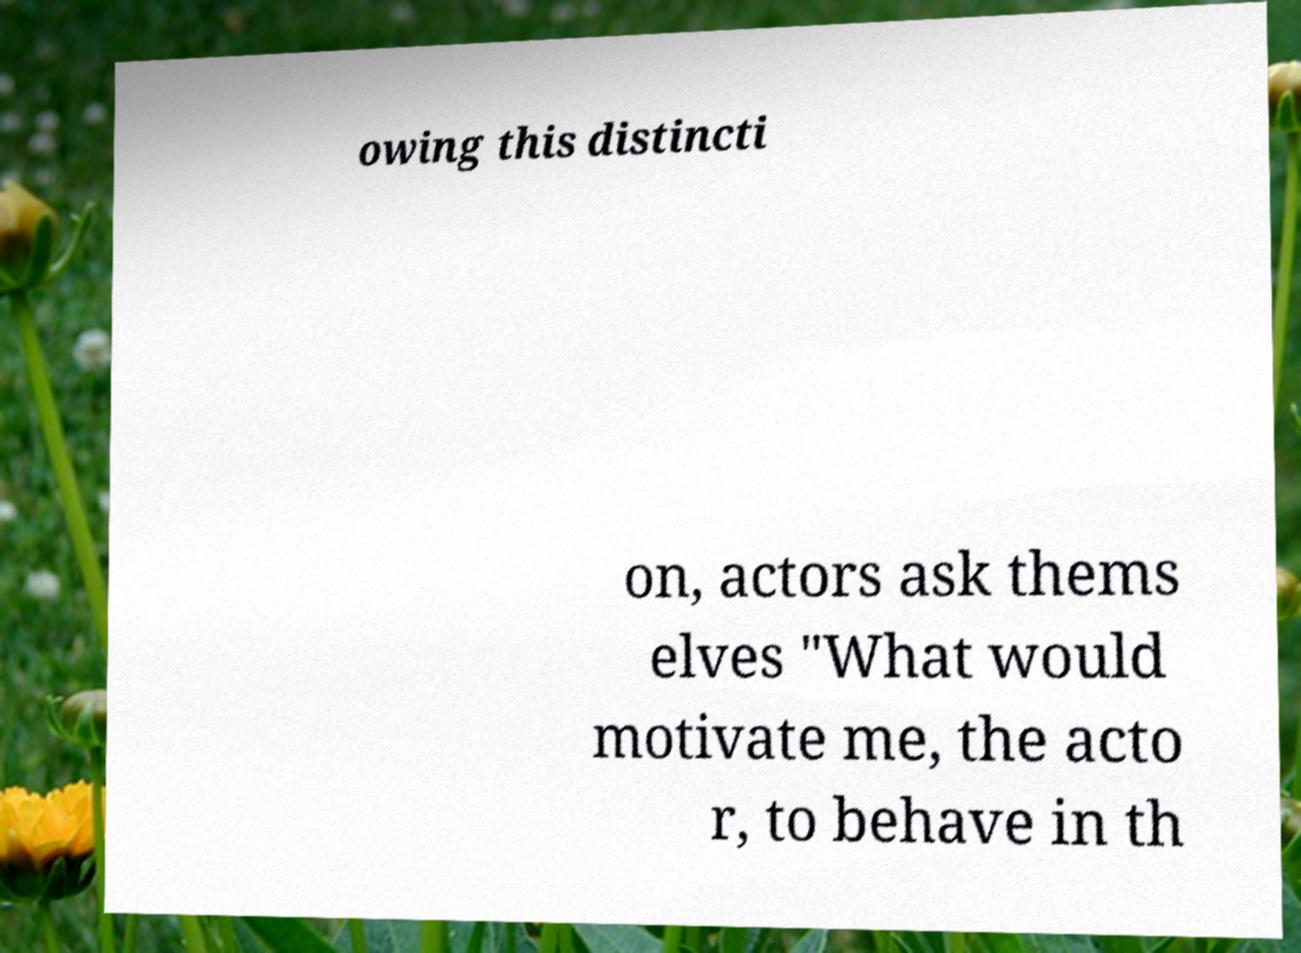Can you accurately transcribe the text from the provided image for me? owing this distincti on, actors ask thems elves "What would motivate me, the acto r, to behave in th 